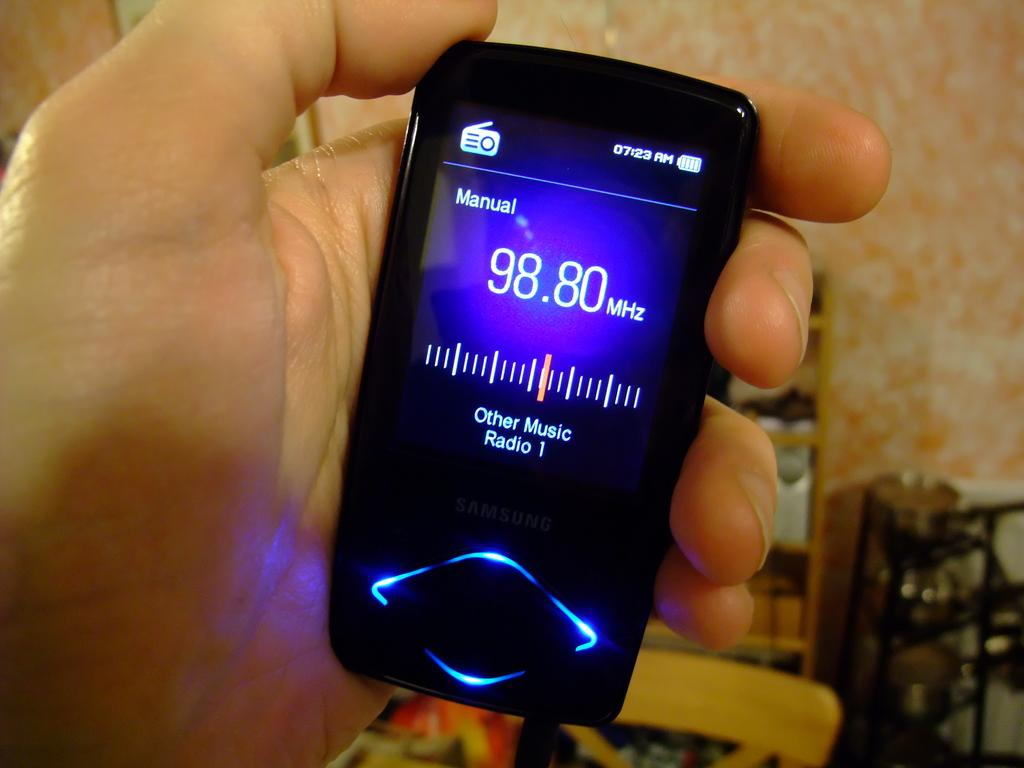What is the person in the image holding? The person is holding a mobile in the image. What type of furniture is visible in the image? There is a chair in the image. What type of storage unit is present in the image? There is a closet in the image. What other objects can be seen at the bottom of the image? There are other objects at the bottom of the image, but their specific details are not mentioned in the provided facts. How does the person in the image push the donkey to move it? There is no donkey present in the image, so the person cannot push it. 